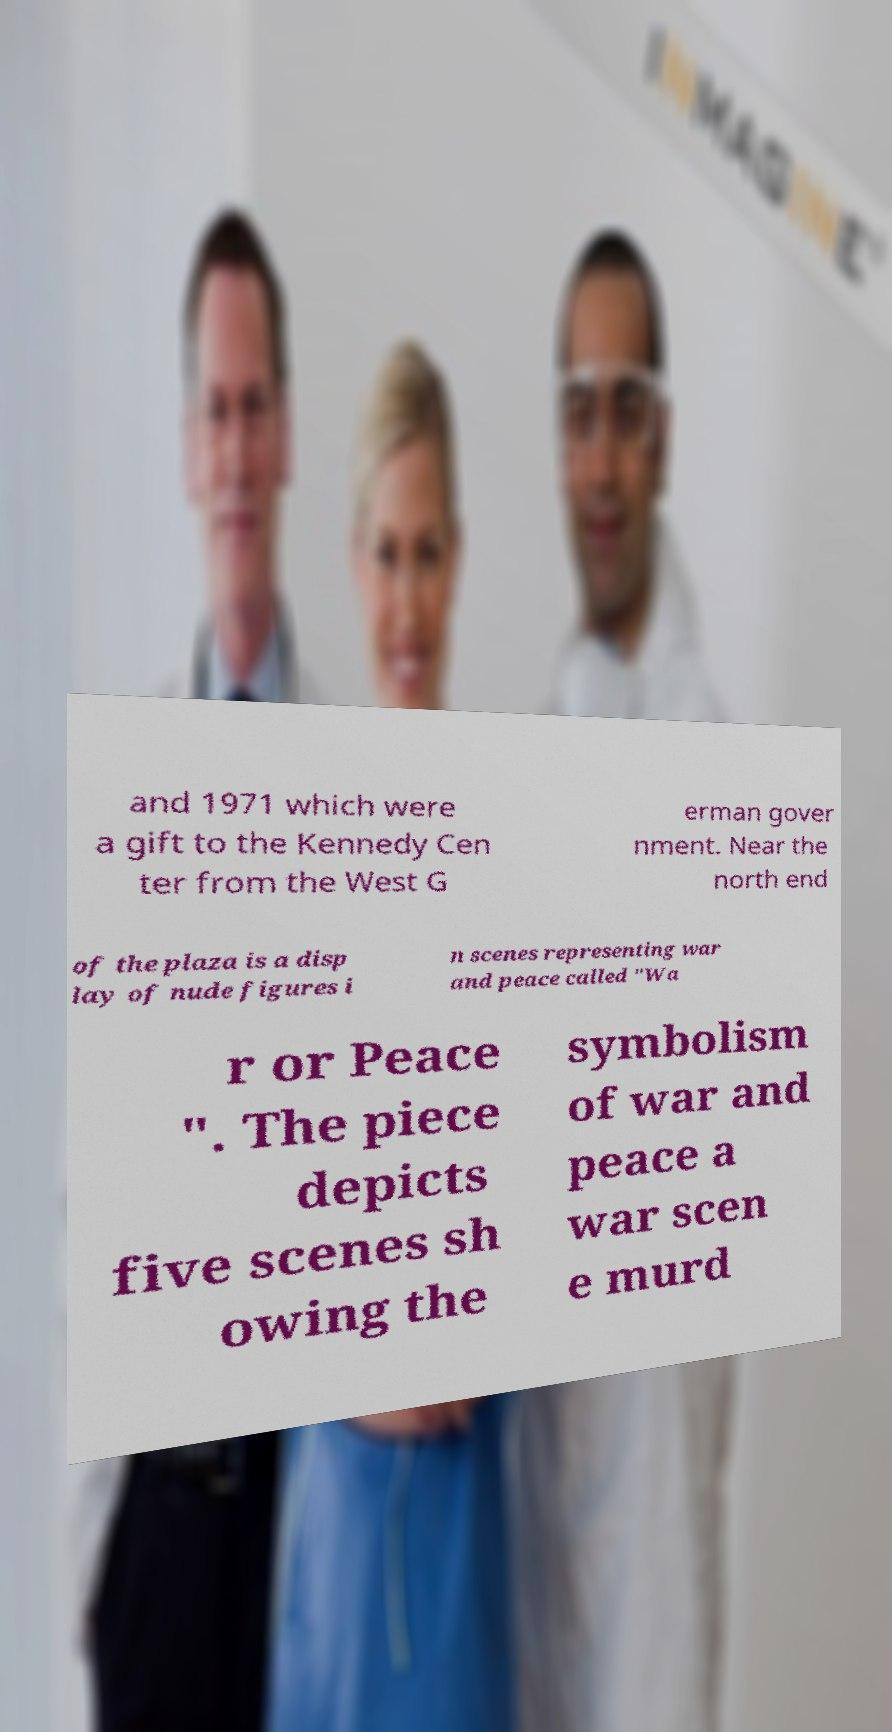There's text embedded in this image that I need extracted. Can you transcribe it verbatim? and 1971 which were a gift to the Kennedy Cen ter from the West G erman gover nment. Near the north end of the plaza is a disp lay of nude figures i n scenes representing war and peace called "Wa r or Peace ". The piece depicts five scenes sh owing the symbolism of war and peace a war scen e murd 